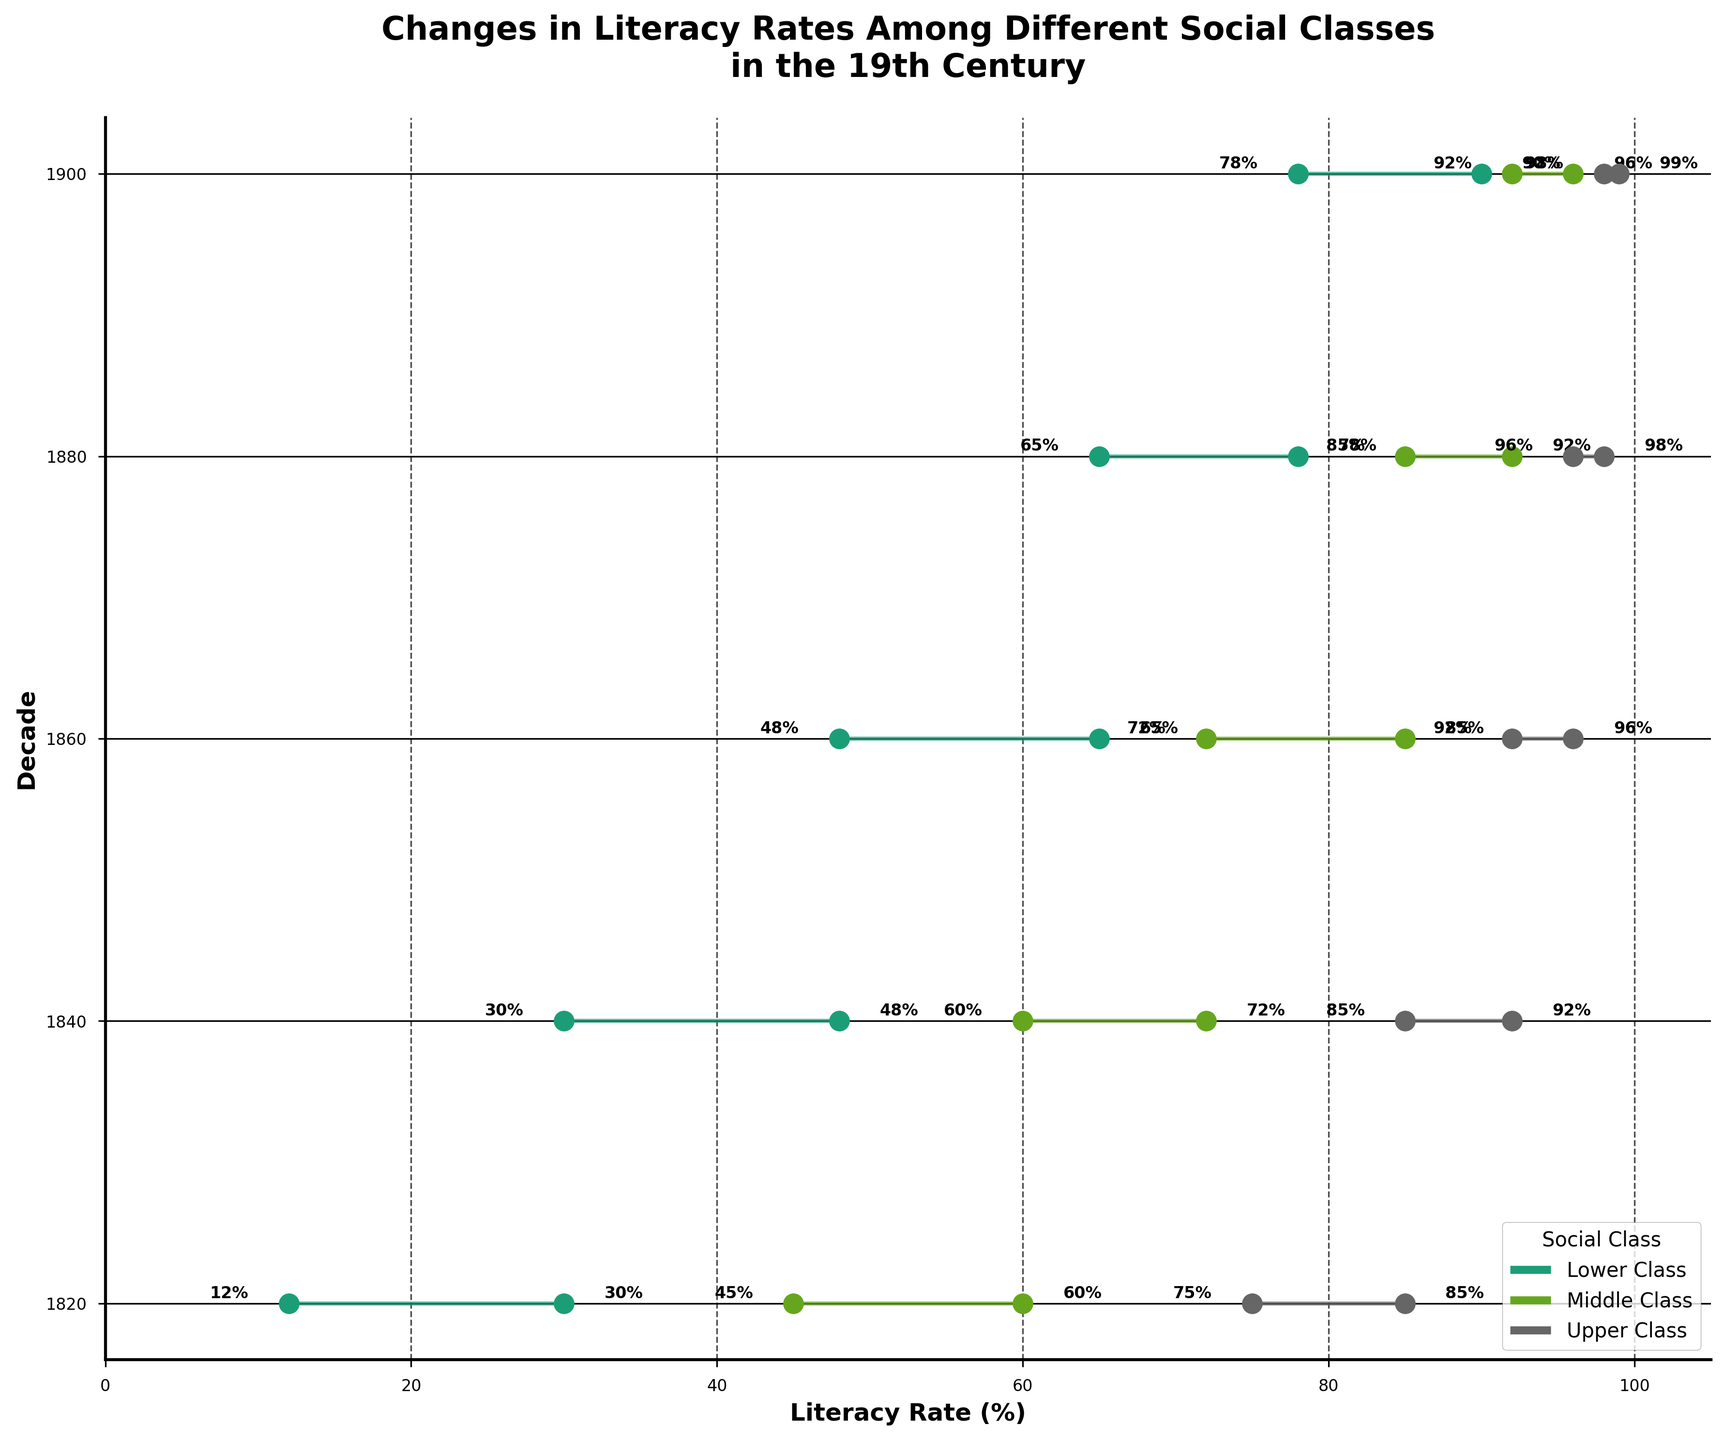What is the literacy rate range for the lower class in 1860? To find this, we locate the lower class data for 1860. The literacy rate starts at 48% and ends at 65%, so the range is from 48% to 65%.
Answer: 48% to 65% Which social class had the smallest increase in literacy rate during the 19th century? To determine the smallest increase, we need to compare the start and end rates for each class across the decades. Summing up, the upper class shows the smallest increases over time, increasing from 75% to 99% (24%) from 1820 to 1900.
Answer: Upper Class How did the literacy rate for the middle class change from 1820 to 1900? The middle class literacy rate increased from 45% in 1820 to 96% in 1900. The change is 96% - 45%, which results in a 51% increase.
Answer: 51% In which decade did the lower class experience its greatest increase in literacy rate? By comparing the increases for the lower class in each period, we see 18% (1820-1840), 17% (1840-1860), 17% (1860-1880), and 12% (1880-1900). The greatest increase was thus from 1820 to 1840.
Answer: 1820 to 1840 What is the title of the chart? The title is found at the top of the plot, which reads, "Changes in Literacy Rates Among Different Social Classes in the 19th Century".
Answer: Changes in Literacy Rates Among Different Social Classes in the 19th Century Compare the rate of increase between the upper class and lower class literacy rates from 1860 to 1880. The upper class increased from 92% to 96%, a 4% increase. The lower class increased from 48% to 65%, a 17% increase. Therefore, the lower class had a much higher increase in literacy rate.
Answer: Lower class had a higher increase Which social class approached near-unanium literacy rate by 1900? The upper class approached near-unanium literacy rate by 1900, climbing to 99%.
Answer: Upper Class What were the literacy rates for all social classes in 1840? Looking at the plot for 1840, the lower class had a rate of 30% to 48%, middle class 60% to 72%, and upper class 85% to 92%.
Answer: Lower: 30%-48%, Middle: 60%-72%, Upper: 85%-92% Which decade recorded the literacy rate crossing 50% for the lower class? The lower class crossed the 50% literacy rate in the 1860s, when it moved from 48% to 65%.
Answer: 1860s How does the start literacy rate for the upper class in 1880 compare to the end rate in 1840? The start literacy rate for the upper class in 1880 was 96%, while the end rate in 1840 was 92%. This indicates an increase of 4% between these two points in time.
Answer: 96% vs. 92% 